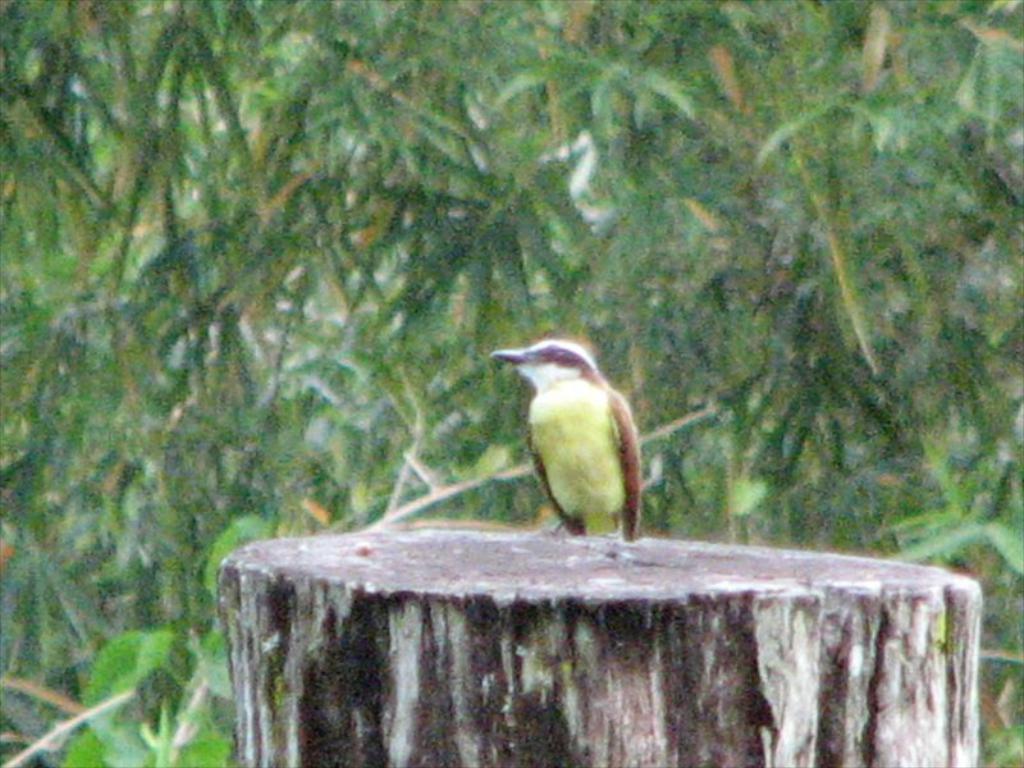Can you describe this image briefly? At the bottom of the image there is a stem, on the stem we can see a bird. Behind the bird there are some trees. Background of the image is blur. 